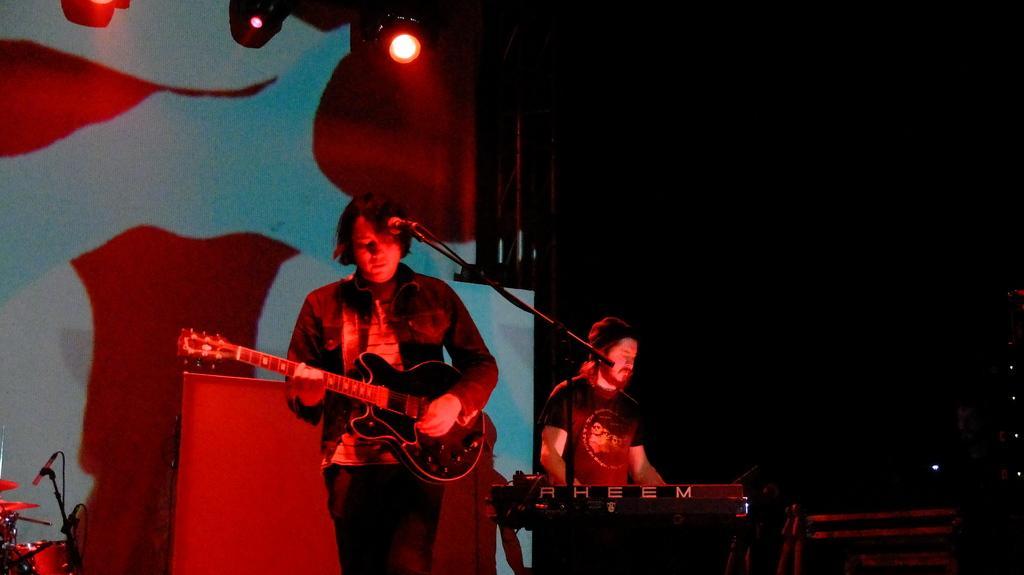Please provide a concise description of this image. In this image I can see two men are standing and here I can see one of them is holding a guitar. I can also see few lights, a drum set, , a mic and I can see this image is in dark from background. 